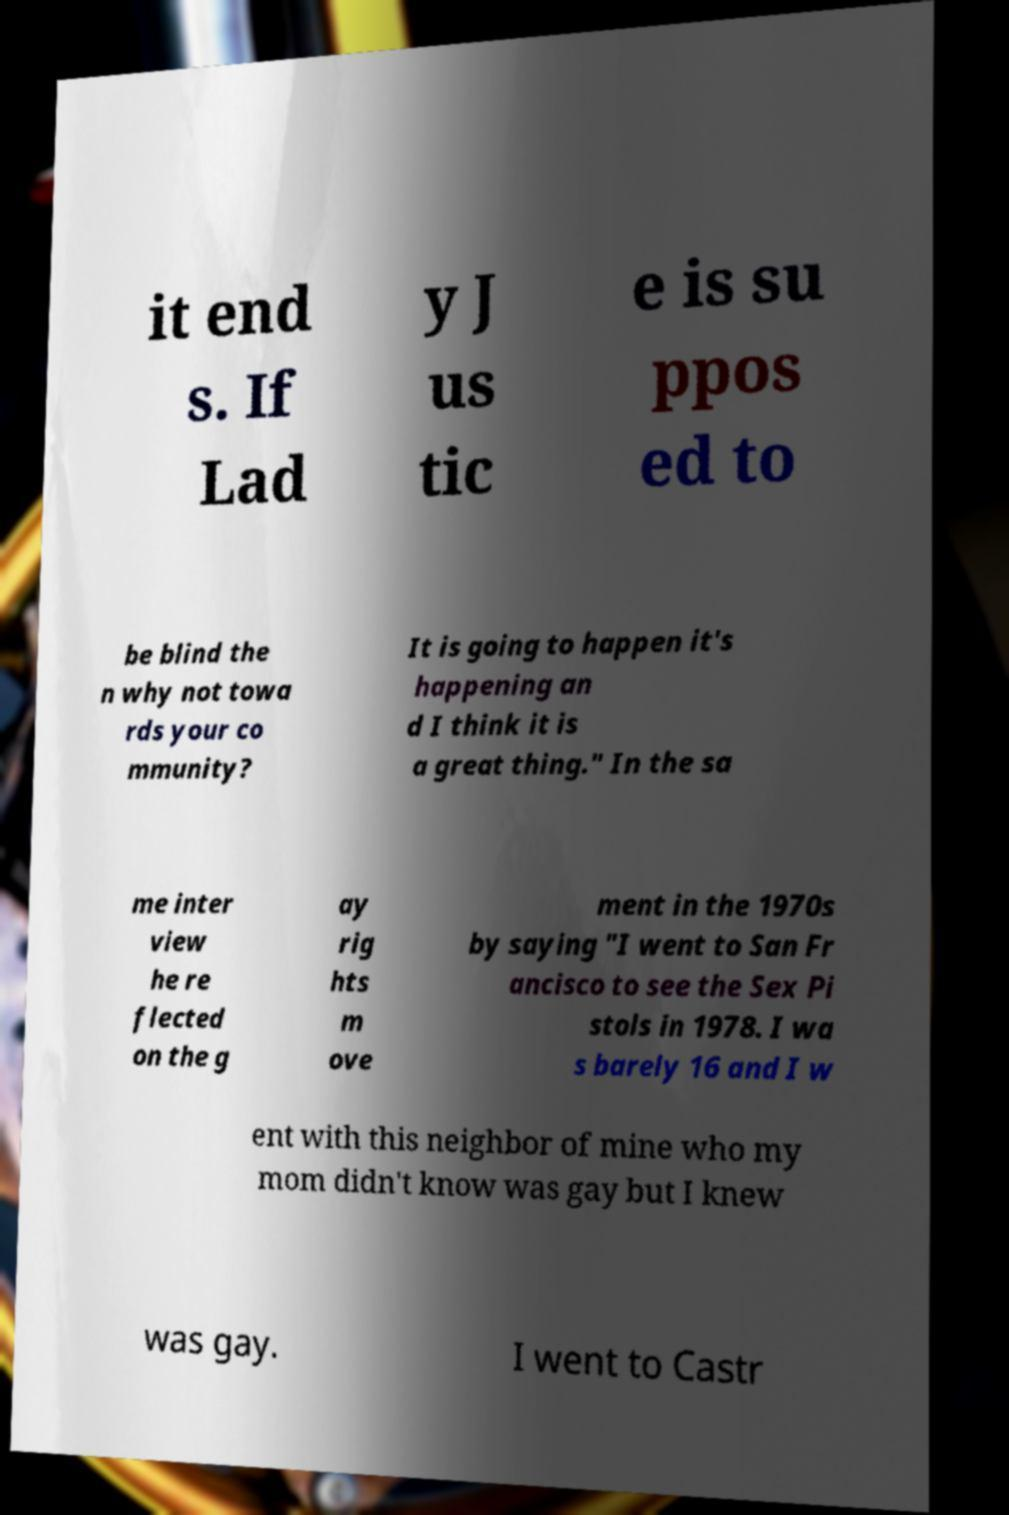Can you accurately transcribe the text from the provided image for me? it end s. If Lad y J us tic e is su ppos ed to be blind the n why not towa rds your co mmunity? It is going to happen it's happening an d I think it is a great thing." In the sa me inter view he re flected on the g ay rig hts m ove ment in the 1970s by saying "I went to San Fr ancisco to see the Sex Pi stols in 1978. I wa s barely 16 and I w ent with this neighbor of mine who my mom didn't know was gay but I knew was gay. I went to Castr 